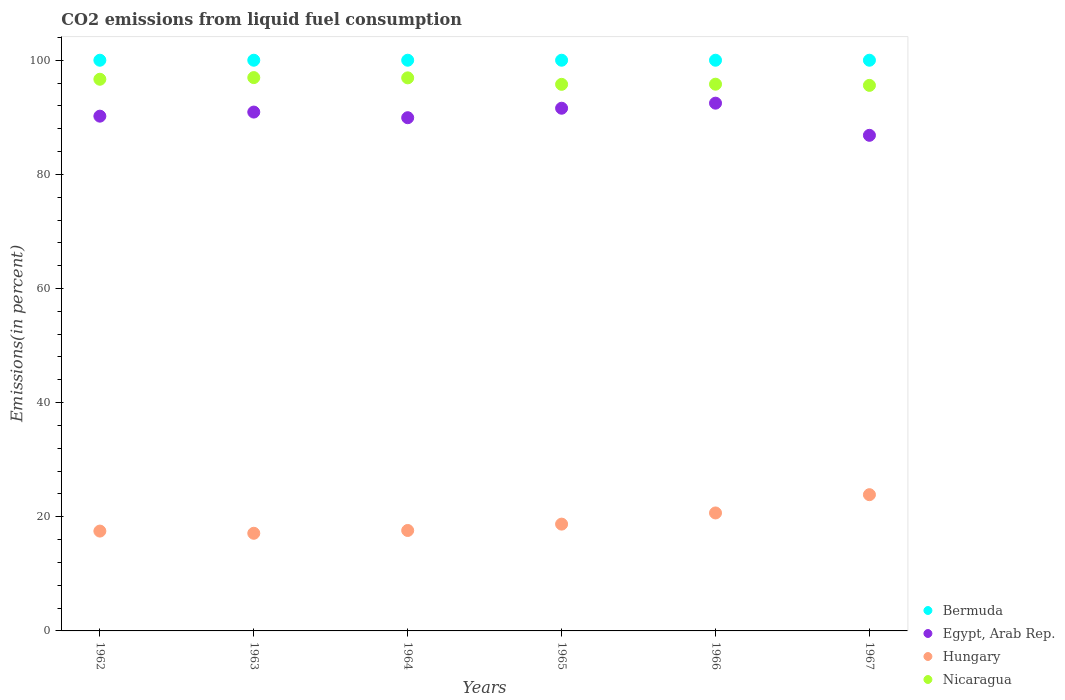How many different coloured dotlines are there?
Ensure brevity in your answer.  4. What is the total CO2 emitted in Nicaragua in 1964?
Ensure brevity in your answer.  96.91. Across all years, what is the maximum total CO2 emitted in Nicaragua?
Offer a very short reply. 96.96. Across all years, what is the minimum total CO2 emitted in Nicaragua?
Your response must be concise. 95.59. In which year was the total CO2 emitted in Hungary maximum?
Give a very brief answer. 1967. In which year was the total CO2 emitted in Nicaragua minimum?
Provide a short and direct response. 1967. What is the total total CO2 emitted in Hungary in the graph?
Provide a succinct answer. 115.46. What is the difference between the total CO2 emitted in Hungary in 1962 and the total CO2 emitted in Bermuda in 1963?
Offer a very short reply. -82.51. In the year 1967, what is the difference between the total CO2 emitted in Hungary and total CO2 emitted in Nicaragua?
Provide a short and direct response. -71.72. What is the ratio of the total CO2 emitted in Bermuda in 1963 to that in 1965?
Keep it short and to the point. 1. Is the difference between the total CO2 emitted in Hungary in 1962 and 1965 greater than the difference between the total CO2 emitted in Nicaragua in 1962 and 1965?
Ensure brevity in your answer.  No. What is the difference between the highest and the second highest total CO2 emitted in Hungary?
Keep it short and to the point. 3.2. What is the difference between the highest and the lowest total CO2 emitted in Egypt, Arab Rep.?
Offer a terse response. 5.63. In how many years, is the total CO2 emitted in Nicaragua greater than the average total CO2 emitted in Nicaragua taken over all years?
Provide a short and direct response. 3. Is the sum of the total CO2 emitted in Hungary in 1965 and 1966 greater than the maximum total CO2 emitted in Egypt, Arab Rep. across all years?
Provide a succinct answer. No. Is it the case that in every year, the sum of the total CO2 emitted in Hungary and total CO2 emitted in Egypt, Arab Rep.  is greater than the sum of total CO2 emitted in Bermuda and total CO2 emitted in Nicaragua?
Offer a terse response. No. Is it the case that in every year, the sum of the total CO2 emitted in Hungary and total CO2 emitted in Bermuda  is greater than the total CO2 emitted in Nicaragua?
Your answer should be very brief. Yes. How many years are there in the graph?
Offer a very short reply. 6. What is the difference between two consecutive major ticks on the Y-axis?
Your answer should be very brief. 20. Are the values on the major ticks of Y-axis written in scientific E-notation?
Your answer should be compact. No. Does the graph contain any zero values?
Your answer should be very brief. No. Does the graph contain grids?
Offer a very short reply. No. How many legend labels are there?
Provide a short and direct response. 4. What is the title of the graph?
Keep it short and to the point. CO2 emissions from liquid fuel consumption. Does "Lebanon" appear as one of the legend labels in the graph?
Your answer should be very brief. No. What is the label or title of the X-axis?
Offer a terse response. Years. What is the label or title of the Y-axis?
Your answer should be very brief. Emissions(in percent). What is the Emissions(in percent) in Egypt, Arab Rep. in 1962?
Provide a short and direct response. 90.2. What is the Emissions(in percent) of Hungary in 1962?
Make the answer very short. 17.49. What is the Emissions(in percent) in Nicaragua in 1962?
Provide a succinct answer. 96.67. What is the Emissions(in percent) in Egypt, Arab Rep. in 1963?
Make the answer very short. 90.92. What is the Emissions(in percent) of Hungary in 1963?
Ensure brevity in your answer.  17.11. What is the Emissions(in percent) in Nicaragua in 1963?
Your answer should be very brief. 96.96. What is the Emissions(in percent) in Bermuda in 1964?
Offer a terse response. 100. What is the Emissions(in percent) of Egypt, Arab Rep. in 1964?
Your answer should be compact. 89.93. What is the Emissions(in percent) in Hungary in 1964?
Keep it short and to the point. 17.6. What is the Emissions(in percent) of Nicaragua in 1964?
Provide a succinct answer. 96.91. What is the Emissions(in percent) of Bermuda in 1965?
Keep it short and to the point. 100. What is the Emissions(in percent) of Egypt, Arab Rep. in 1965?
Provide a short and direct response. 91.59. What is the Emissions(in percent) in Hungary in 1965?
Your response must be concise. 18.71. What is the Emissions(in percent) in Nicaragua in 1965?
Provide a short and direct response. 95.77. What is the Emissions(in percent) in Bermuda in 1966?
Offer a very short reply. 100. What is the Emissions(in percent) of Egypt, Arab Rep. in 1966?
Offer a terse response. 92.48. What is the Emissions(in percent) of Hungary in 1966?
Your answer should be very brief. 20.67. What is the Emissions(in percent) of Nicaragua in 1966?
Make the answer very short. 95.8. What is the Emissions(in percent) of Egypt, Arab Rep. in 1967?
Offer a terse response. 86.84. What is the Emissions(in percent) of Hungary in 1967?
Provide a succinct answer. 23.87. What is the Emissions(in percent) of Nicaragua in 1967?
Ensure brevity in your answer.  95.59. Across all years, what is the maximum Emissions(in percent) in Bermuda?
Give a very brief answer. 100. Across all years, what is the maximum Emissions(in percent) of Egypt, Arab Rep.?
Offer a terse response. 92.48. Across all years, what is the maximum Emissions(in percent) in Hungary?
Make the answer very short. 23.87. Across all years, what is the maximum Emissions(in percent) of Nicaragua?
Provide a succinct answer. 96.96. Across all years, what is the minimum Emissions(in percent) of Bermuda?
Offer a very short reply. 100. Across all years, what is the minimum Emissions(in percent) in Egypt, Arab Rep.?
Offer a terse response. 86.84. Across all years, what is the minimum Emissions(in percent) of Hungary?
Offer a terse response. 17.11. Across all years, what is the minimum Emissions(in percent) in Nicaragua?
Provide a short and direct response. 95.59. What is the total Emissions(in percent) of Bermuda in the graph?
Offer a terse response. 600. What is the total Emissions(in percent) in Egypt, Arab Rep. in the graph?
Your answer should be very brief. 541.95. What is the total Emissions(in percent) in Hungary in the graph?
Your answer should be compact. 115.46. What is the total Emissions(in percent) in Nicaragua in the graph?
Keep it short and to the point. 577.7. What is the difference between the Emissions(in percent) of Bermuda in 1962 and that in 1963?
Your answer should be compact. 0. What is the difference between the Emissions(in percent) in Egypt, Arab Rep. in 1962 and that in 1963?
Offer a terse response. -0.72. What is the difference between the Emissions(in percent) of Hungary in 1962 and that in 1963?
Make the answer very short. 0.38. What is the difference between the Emissions(in percent) of Nicaragua in 1962 and that in 1963?
Provide a succinct answer. -0.29. What is the difference between the Emissions(in percent) of Egypt, Arab Rep. in 1962 and that in 1964?
Provide a short and direct response. 0.27. What is the difference between the Emissions(in percent) of Hungary in 1962 and that in 1964?
Provide a short and direct response. -0.11. What is the difference between the Emissions(in percent) in Nicaragua in 1962 and that in 1964?
Give a very brief answer. -0.24. What is the difference between the Emissions(in percent) in Egypt, Arab Rep. in 1962 and that in 1965?
Make the answer very short. -1.39. What is the difference between the Emissions(in percent) of Hungary in 1962 and that in 1965?
Offer a very short reply. -1.22. What is the difference between the Emissions(in percent) of Nicaragua in 1962 and that in 1965?
Provide a succinct answer. 0.89. What is the difference between the Emissions(in percent) in Bermuda in 1962 and that in 1966?
Make the answer very short. 0. What is the difference between the Emissions(in percent) in Egypt, Arab Rep. in 1962 and that in 1966?
Your answer should be very brief. -2.28. What is the difference between the Emissions(in percent) in Hungary in 1962 and that in 1966?
Make the answer very short. -3.18. What is the difference between the Emissions(in percent) in Nicaragua in 1962 and that in 1966?
Your response must be concise. 0.87. What is the difference between the Emissions(in percent) in Egypt, Arab Rep. in 1962 and that in 1967?
Offer a terse response. 3.36. What is the difference between the Emissions(in percent) of Hungary in 1962 and that in 1967?
Your answer should be very brief. -6.38. What is the difference between the Emissions(in percent) in Nicaragua in 1962 and that in 1967?
Your answer should be very brief. 1.07. What is the difference between the Emissions(in percent) of Egypt, Arab Rep. in 1963 and that in 1964?
Offer a very short reply. 0.99. What is the difference between the Emissions(in percent) in Hungary in 1963 and that in 1964?
Provide a short and direct response. -0.49. What is the difference between the Emissions(in percent) in Nicaragua in 1963 and that in 1964?
Offer a terse response. 0.05. What is the difference between the Emissions(in percent) in Egypt, Arab Rep. in 1963 and that in 1965?
Provide a short and direct response. -0.67. What is the difference between the Emissions(in percent) in Hungary in 1963 and that in 1965?
Offer a terse response. -1.6. What is the difference between the Emissions(in percent) in Nicaragua in 1963 and that in 1965?
Make the answer very short. 1.18. What is the difference between the Emissions(in percent) of Egypt, Arab Rep. in 1963 and that in 1966?
Make the answer very short. -1.56. What is the difference between the Emissions(in percent) in Hungary in 1963 and that in 1966?
Provide a succinct answer. -3.56. What is the difference between the Emissions(in percent) of Nicaragua in 1963 and that in 1966?
Make the answer very short. 1.16. What is the difference between the Emissions(in percent) of Egypt, Arab Rep. in 1963 and that in 1967?
Your answer should be compact. 4.07. What is the difference between the Emissions(in percent) of Hungary in 1963 and that in 1967?
Provide a short and direct response. -6.76. What is the difference between the Emissions(in percent) of Nicaragua in 1963 and that in 1967?
Ensure brevity in your answer.  1.36. What is the difference between the Emissions(in percent) in Bermuda in 1964 and that in 1965?
Keep it short and to the point. 0. What is the difference between the Emissions(in percent) in Egypt, Arab Rep. in 1964 and that in 1965?
Your answer should be very brief. -1.66. What is the difference between the Emissions(in percent) in Hungary in 1964 and that in 1965?
Provide a succinct answer. -1.11. What is the difference between the Emissions(in percent) in Nicaragua in 1964 and that in 1965?
Your answer should be very brief. 1.14. What is the difference between the Emissions(in percent) in Egypt, Arab Rep. in 1964 and that in 1966?
Provide a short and direct response. -2.55. What is the difference between the Emissions(in percent) in Hungary in 1964 and that in 1966?
Ensure brevity in your answer.  -3.07. What is the difference between the Emissions(in percent) in Nicaragua in 1964 and that in 1966?
Provide a short and direct response. 1.11. What is the difference between the Emissions(in percent) in Egypt, Arab Rep. in 1964 and that in 1967?
Keep it short and to the point. 3.09. What is the difference between the Emissions(in percent) of Hungary in 1964 and that in 1967?
Provide a short and direct response. -6.27. What is the difference between the Emissions(in percent) of Nicaragua in 1964 and that in 1967?
Your response must be concise. 1.32. What is the difference between the Emissions(in percent) of Bermuda in 1965 and that in 1966?
Provide a succinct answer. 0. What is the difference between the Emissions(in percent) of Egypt, Arab Rep. in 1965 and that in 1966?
Your response must be concise. -0.89. What is the difference between the Emissions(in percent) of Hungary in 1965 and that in 1966?
Ensure brevity in your answer.  -1.96. What is the difference between the Emissions(in percent) in Nicaragua in 1965 and that in 1966?
Keep it short and to the point. -0.03. What is the difference between the Emissions(in percent) in Egypt, Arab Rep. in 1965 and that in 1967?
Provide a short and direct response. 4.75. What is the difference between the Emissions(in percent) in Hungary in 1965 and that in 1967?
Keep it short and to the point. -5.16. What is the difference between the Emissions(in percent) in Nicaragua in 1965 and that in 1967?
Offer a terse response. 0.18. What is the difference between the Emissions(in percent) in Egypt, Arab Rep. in 1966 and that in 1967?
Give a very brief answer. 5.63. What is the difference between the Emissions(in percent) of Hungary in 1966 and that in 1967?
Offer a very short reply. -3.2. What is the difference between the Emissions(in percent) of Nicaragua in 1966 and that in 1967?
Offer a very short reply. 0.21. What is the difference between the Emissions(in percent) of Bermuda in 1962 and the Emissions(in percent) of Egypt, Arab Rep. in 1963?
Offer a terse response. 9.08. What is the difference between the Emissions(in percent) in Bermuda in 1962 and the Emissions(in percent) in Hungary in 1963?
Your answer should be compact. 82.89. What is the difference between the Emissions(in percent) of Bermuda in 1962 and the Emissions(in percent) of Nicaragua in 1963?
Your answer should be very brief. 3.04. What is the difference between the Emissions(in percent) of Egypt, Arab Rep. in 1962 and the Emissions(in percent) of Hungary in 1963?
Ensure brevity in your answer.  73.09. What is the difference between the Emissions(in percent) of Egypt, Arab Rep. in 1962 and the Emissions(in percent) of Nicaragua in 1963?
Ensure brevity in your answer.  -6.76. What is the difference between the Emissions(in percent) in Hungary in 1962 and the Emissions(in percent) in Nicaragua in 1963?
Ensure brevity in your answer.  -79.46. What is the difference between the Emissions(in percent) of Bermuda in 1962 and the Emissions(in percent) of Egypt, Arab Rep. in 1964?
Give a very brief answer. 10.07. What is the difference between the Emissions(in percent) of Bermuda in 1962 and the Emissions(in percent) of Hungary in 1964?
Offer a terse response. 82.4. What is the difference between the Emissions(in percent) in Bermuda in 1962 and the Emissions(in percent) in Nicaragua in 1964?
Give a very brief answer. 3.09. What is the difference between the Emissions(in percent) in Egypt, Arab Rep. in 1962 and the Emissions(in percent) in Hungary in 1964?
Offer a very short reply. 72.6. What is the difference between the Emissions(in percent) of Egypt, Arab Rep. in 1962 and the Emissions(in percent) of Nicaragua in 1964?
Give a very brief answer. -6.71. What is the difference between the Emissions(in percent) of Hungary in 1962 and the Emissions(in percent) of Nicaragua in 1964?
Your response must be concise. -79.42. What is the difference between the Emissions(in percent) in Bermuda in 1962 and the Emissions(in percent) in Egypt, Arab Rep. in 1965?
Your answer should be very brief. 8.41. What is the difference between the Emissions(in percent) in Bermuda in 1962 and the Emissions(in percent) in Hungary in 1965?
Ensure brevity in your answer.  81.29. What is the difference between the Emissions(in percent) in Bermuda in 1962 and the Emissions(in percent) in Nicaragua in 1965?
Your response must be concise. 4.23. What is the difference between the Emissions(in percent) of Egypt, Arab Rep. in 1962 and the Emissions(in percent) of Hungary in 1965?
Provide a succinct answer. 71.49. What is the difference between the Emissions(in percent) of Egypt, Arab Rep. in 1962 and the Emissions(in percent) of Nicaragua in 1965?
Your response must be concise. -5.58. What is the difference between the Emissions(in percent) in Hungary in 1962 and the Emissions(in percent) in Nicaragua in 1965?
Keep it short and to the point. -78.28. What is the difference between the Emissions(in percent) in Bermuda in 1962 and the Emissions(in percent) in Egypt, Arab Rep. in 1966?
Your answer should be compact. 7.52. What is the difference between the Emissions(in percent) of Bermuda in 1962 and the Emissions(in percent) of Hungary in 1966?
Offer a very short reply. 79.33. What is the difference between the Emissions(in percent) in Bermuda in 1962 and the Emissions(in percent) in Nicaragua in 1966?
Ensure brevity in your answer.  4.2. What is the difference between the Emissions(in percent) in Egypt, Arab Rep. in 1962 and the Emissions(in percent) in Hungary in 1966?
Your answer should be very brief. 69.53. What is the difference between the Emissions(in percent) in Egypt, Arab Rep. in 1962 and the Emissions(in percent) in Nicaragua in 1966?
Your response must be concise. -5.6. What is the difference between the Emissions(in percent) in Hungary in 1962 and the Emissions(in percent) in Nicaragua in 1966?
Your answer should be compact. -78.31. What is the difference between the Emissions(in percent) in Bermuda in 1962 and the Emissions(in percent) in Egypt, Arab Rep. in 1967?
Make the answer very short. 13.16. What is the difference between the Emissions(in percent) of Bermuda in 1962 and the Emissions(in percent) of Hungary in 1967?
Give a very brief answer. 76.13. What is the difference between the Emissions(in percent) in Bermuda in 1962 and the Emissions(in percent) in Nicaragua in 1967?
Provide a short and direct response. 4.41. What is the difference between the Emissions(in percent) in Egypt, Arab Rep. in 1962 and the Emissions(in percent) in Hungary in 1967?
Keep it short and to the point. 66.33. What is the difference between the Emissions(in percent) in Egypt, Arab Rep. in 1962 and the Emissions(in percent) in Nicaragua in 1967?
Your answer should be very brief. -5.39. What is the difference between the Emissions(in percent) of Hungary in 1962 and the Emissions(in percent) of Nicaragua in 1967?
Provide a short and direct response. -78.1. What is the difference between the Emissions(in percent) in Bermuda in 1963 and the Emissions(in percent) in Egypt, Arab Rep. in 1964?
Offer a very short reply. 10.07. What is the difference between the Emissions(in percent) of Bermuda in 1963 and the Emissions(in percent) of Hungary in 1964?
Ensure brevity in your answer.  82.4. What is the difference between the Emissions(in percent) of Bermuda in 1963 and the Emissions(in percent) of Nicaragua in 1964?
Provide a succinct answer. 3.09. What is the difference between the Emissions(in percent) in Egypt, Arab Rep. in 1963 and the Emissions(in percent) in Hungary in 1964?
Your answer should be compact. 73.32. What is the difference between the Emissions(in percent) in Egypt, Arab Rep. in 1963 and the Emissions(in percent) in Nicaragua in 1964?
Ensure brevity in your answer.  -6. What is the difference between the Emissions(in percent) of Hungary in 1963 and the Emissions(in percent) of Nicaragua in 1964?
Ensure brevity in your answer.  -79.8. What is the difference between the Emissions(in percent) of Bermuda in 1963 and the Emissions(in percent) of Egypt, Arab Rep. in 1965?
Offer a very short reply. 8.41. What is the difference between the Emissions(in percent) of Bermuda in 1963 and the Emissions(in percent) of Hungary in 1965?
Provide a short and direct response. 81.29. What is the difference between the Emissions(in percent) in Bermuda in 1963 and the Emissions(in percent) in Nicaragua in 1965?
Your answer should be compact. 4.23. What is the difference between the Emissions(in percent) in Egypt, Arab Rep. in 1963 and the Emissions(in percent) in Hungary in 1965?
Your answer should be compact. 72.2. What is the difference between the Emissions(in percent) in Egypt, Arab Rep. in 1963 and the Emissions(in percent) in Nicaragua in 1965?
Offer a terse response. -4.86. What is the difference between the Emissions(in percent) of Hungary in 1963 and the Emissions(in percent) of Nicaragua in 1965?
Provide a succinct answer. -78.66. What is the difference between the Emissions(in percent) in Bermuda in 1963 and the Emissions(in percent) in Egypt, Arab Rep. in 1966?
Make the answer very short. 7.52. What is the difference between the Emissions(in percent) in Bermuda in 1963 and the Emissions(in percent) in Hungary in 1966?
Your response must be concise. 79.33. What is the difference between the Emissions(in percent) in Bermuda in 1963 and the Emissions(in percent) in Nicaragua in 1966?
Your response must be concise. 4.2. What is the difference between the Emissions(in percent) of Egypt, Arab Rep. in 1963 and the Emissions(in percent) of Hungary in 1966?
Give a very brief answer. 70.24. What is the difference between the Emissions(in percent) of Egypt, Arab Rep. in 1963 and the Emissions(in percent) of Nicaragua in 1966?
Your answer should be compact. -4.89. What is the difference between the Emissions(in percent) in Hungary in 1963 and the Emissions(in percent) in Nicaragua in 1966?
Make the answer very short. -78.69. What is the difference between the Emissions(in percent) of Bermuda in 1963 and the Emissions(in percent) of Egypt, Arab Rep. in 1967?
Ensure brevity in your answer.  13.16. What is the difference between the Emissions(in percent) in Bermuda in 1963 and the Emissions(in percent) in Hungary in 1967?
Provide a succinct answer. 76.13. What is the difference between the Emissions(in percent) of Bermuda in 1963 and the Emissions(in percent) of Nicaragua in 1967?
Keep it short and to the point. 4.41. What is the difference between the Emissions(in percent) in Egypt, Arab Rep. in 1963 and the Emissions(in percent) in Hungary in 1967?
Your response must be concise. 67.04. What is the difference between the Emissions(in percent) in Egypt, Arab Rep. in 1963 and the Emissions(in percent) in Nicaragua in 1967?
Keep it short and to the point. -4.68. What is the difference between the Emissions(in percent) of Hungary in 1963 and the Emissions(in percent) of Nicaragua in 1967?
Provide a short and direct response. -78.48. What is the difference between the Emissions(in percent) in Bermuda in 1964 and the Emissions(in percent) in Egypt, Arab Rep. in 1965?
Offer a terse response. 8.41. What is the difference between the Emissions(in percent) of Bermuda in 1964 and the Emissions(in percent) of Hungary in 1965?
Provide a succinct answer. 81.29. What is the difference between the Emissions(in percent) of Bermuda in 1964 and the Emissions(in percent) of Nicaragua in 1965?
Your answer should be very brief. 4.23. What is the difference between the Emissions(in percent) of Egypt, Arab Rep. in 1964 and the Emissions(in percent) of Hungary in 1965?
Keep it short and to the point. 71.21. What is the difference between the Emissions(in percent) in Egypt, Arab Rep. in 1964 and the Emissions(in percent) in Nicaragua in 1965?
Make the answer very short. -5.85. What is the difference between the Emissions(in percent) in Hungary in 1964 and the Emissions(in percent) in Nicaragua in 1965?
Make the answer very short. -78.17. What is the difference between the Emissions(in percent) in Bermuda in 1964 and the Emissions(in percent) in Egypt, Arab Rep. in 1966?
Your answer should be compact. 7.52. What is the difference between the Emissions(in percent) of Bermuda in 1964 and the Emissions(in percent) of Hungary in 1966?
Make the answer very short. 79.33. What is the difference between the Emissions(in percent) of Bermuda in 1964 and the Emissions(in percent) of Nicaragua in 1966?
Give a very brief answer. 4.2. What is the difference between the Emissions(in percent) in Egypt, Arab Rep. in 1964 and the Emissions(in percent) in Hungary in 1966?
Offer a terse response. 69.26. What is the difference between the Emissions(in percent) of Egypt, Arab Rep. in 1964 and the Emissions(in percent) of Nicaragua in 1966?
Keep it short and to the point. -5.87. What is the difference between the Emissions(in percent) in Hungary in 1964 and the Emissions(in percent) in Nicaragua in 1966?
Give a very brief answer. -78.2. What is the difference between the Emissions(in percent) of Bermuda in 1964 and the Emissions(in percent) of Egypt, Arab Rep. in 1967?
Keep it short and to the point. 13.16. What is the difference between the Emissions(in percent) in Bermuda in 1964 and the Emissions(in percent) in Hungary in 1967?
Make the answer very short. 76.13. What is the difference between the Emissions(in percent) in Bermuda in 1964 and the Emissions(in percent) in Nicaragua in 1967?
Keep it short and to the point. 4.41. What is the difference between the Emissions(in percent) of Egypt, Arab Rep. in 1964 and the Emissions(in percent) of Hungary in 1967?
Ensure brevity in your answer.  66.05. What is the difference between the Emissions(in percent) in Egypt, Arab Rep. in 1964 and the Emissions(in percent) in Nicaragua in 1967?
Provide a succinct answer. -5.67. What is the difference between the Emissions(in percent) in Hungary in 1964 and the Emissions(in percent) in Nicaragua in 1967?
Offer a very short reply. -77.99. What is the difference between the Emissions(in percent) in Bermuda in 1965 and the Emissions(in percent) in Egypt, Arab Rep. in 1966?
Offer a terse response. 7.52. What is the difference between the Emissions(in percent) in Bermuda in 1965 and the Emissions(in percent) in Hungary in 1966?
Offer a very short reply. 79.33. What is the difference between the Emissions(in percent) of Bermuda in 1965 and the Emissions(in percent) of Nicaragua in 1966?
Offer a very short reply. 4.2. What is the difference between the Emissions(in percent) in Egypt, Arab Rep. in 1965 and the Emissions(in percent) in Hungary in 1966?
Give a very brief answer. 70.92. What is the difference between the Emissions(in percent) in Egypt, Arab Rep. in 1965 and the Emissions(in percent) in Nicaragua in 1966?
Offer a very short reply. -4.21. What is the difference between the Emissions(in percent) in Hungary in 1965 and the Emissions(in percent) in Nicaragua in 1966?
Keep it short and to the point. -77.09. What is the difference between the Emissions(in percent) in Bermuda in 1965 and the Emissions(in percent) in Egypt, Arab Rep. in 1967?
Your response must be concise. 13.16. What is the difference between the Emissions(in percent) in Bermuda in 1965 and the Emissions(in percent) in Hungary in 1967?
Keep it short and to the point. 76.13. What is the difference between the Emissions(in percent) of Bermuda in 1965 and the Emissions(in percent) of Nicaragua in 1967?
Provide a short and direct response. 4.41. What is the difference between the Emissions(in percent) of Egypt, Arab Rep. in 1965 and the Emissions(in percent) of Hungary in 1967?
Provide a short and direct response. 67.72. What is the difference between the Emissions(in percent) in Egypt, Arab Rep. in 1965 and the Emissions(in percent) in Nicaragua in 1967?
Your answer should be very brief. -4. What is the difference between the Emissions(in percent) in Hungary in 1965 and the Emissions(in percent) in Nicaragua in 1967?
Provide a short and direct response. -76.88. What is the difference between the Emissions(in percent) in Bermuda in 1966 and the Emissions(in percent) in Egypt, Arab Rep. in 1967?
Provide a short and direct response. 13.16. What is the difference between the Emissions(in percent) of Bermuda in 1966 and the Emissions(in percent) of Hungary in 1967?
Ensure brevity in your answer.  76.13. What is the difference between the Emissions(in percent) of Bermuda in 1966 and the Emissions(in percent) of Nicaragua in 1967?
Your answer should be compact. 4.41. What is the difference between the Emissions(in percent) in Egypt, Arab Rep. in 1966 and the Emissions(in percent) in Hungary in 1967?
Provide a short and direct response. 68.6. What is the difference between the Emissions(in percent) in Egypt, Arab Rep. in 1966 and the Emissions(in percent) in Nicaragua in 1967?
Make the answer very short. -3.12. What is the difference between the Emissions(in percent) of Hungary in 1966 and the Emissions(in percent) of Nicaragua in 1967?
Give a very brief answer. -74.92. What is the average Emissions(in percent) in Egypt, Arab Rep. per year?
Provide a succinct answer. 90.33. What is the average Emissions(in percent) in Hungary per year?
Make the answer very short. 19.24. What is the average Emissions(in percent) in Nicaragua per year?
Offer a terse response. 96.28. In the year 1962, what is the difference between the Emissions(in percent) of Bermuda and Emissions(in percent) of Egypt, Arab Rep.?
Provide a short and direct response. 9.8. In the year 1962, what is the difference between the Emissions(in percent) in Bermuda and Emissions(in percent) in Hungary?
Give a very brief answer. 82.51. In the year 1962, what is the difference between the Emissions(in percent) of Bermuda and Emissions(in percent) of Nicaragua?
Keep it short and to the point. 3.33. In the year 1962, what is the difference between the Emissions(in percent) in Egypt, Arab Rep. and Emissions(in percent) in Hungary?
Provide a short and direct response. 72.71. In the year 1962, what is the difference between the Emissions(in percent) of Egypt, Arab Rep. and Emissions(in percent) of Nicaragua?
Keep it short and to the point. -6.47. In the year 1962, what is the difference between the Emissions(in percent) in Hungary and Emissions(in percent) in Nicaragua?
Make the answer very short. -79.17. In the year 1963, what is the difference between the Emissions(in percent) in Bermuda and Emissions(in percent) in Egypt, Arab Rep.?
Provide a short and direct response. 9.08. In the year 1963, what is the difference between the Emissions(in percent) of Bermuda and Emissions(in percent) of Hungary?
Make the answer very short. 82.89. In the year 1963, what is the difference between the Emissions(in percent) of Bermuda and Emissions(in percent) of Nicaragua?
Offer a very short reply. 3.04. In the year 1963, what is the difference between the Emissions(in percent) of Egypt, Arab Rep. and Emissions(in percent) of Hungary?
Your response must be concise. 73.81. In the year 1963, what is the difference between the Emissions(in percent) of Egypt, Arab Rep. and Emissions(in percent) of Nicaragua?
Your answer should be very brief. -6.04. In the year 1963, what is the difference between the Emissions(in percent) of Hungary and Emissions(in percent) of Nicaragua?
Your response must be concise. -79.85. In the year 1964, what is the difference between the Emissions(in percent) in Bermuda and Emissions(in percent) in Egypt, Arab Rep.?
Your response must be concise. 10.07. In the year 1964, what is the difference between the Emissions(in percent) in Bermuda and Emissions(in percent) in Hungary?
Your response must be concise. 82.4. In the year 1964, what is the difference between the Emissions(in percent) of Bermuda and Emissions(in percent) of Nicaragua?
Your response must be concise. 3.09. In the year 1964, what is the difference between the Emissions(in percent) of Egypt, Arab Rep. and Emissions(in percent) of Hungary?
Your answer should be compact. 72.33. In the year 1964, what is the difference between the Emissions(in percent) in Egypt, Arab Rep. and Emissions(in percent) in Nicaragua?
Give a very brief answer. -6.98. In the year 1964, what is the difference between the Emissions(in percent) of Hungary and Emissions(in percent) of Nicaragua?
Keep it short and to the point. -79.31. In the year 1965, what is the difference between the Emissions(in percent) in Bermuda and Emissions(in percent) in Egypt, Arab Rep.?
Offer a very short reply. 8.41. In the year 1965, what is the difference between the Emissions(in percent) of Bermuda and Emissions(in percent) of Hungary?
Offer a terse response. 81.29. In the year 1965, what is the difference between the Emissions(in percent) of Bermuda and Emissions(in percent) of Nicaragua?
Make the answer very short. 4.23. In the year 1965, what is the difference between the Emissions(in percent) in Egypt, Arab Rep. and Emissions(in percent) in Hungary?
Provide a succinct answer. 72.88. In the year 1965, what is the difference between the Emissions(in percent) in Egypt, Arab Rep. and Emissions(in percent) in Nicaragua?
Provide a short and direct response. -4.19. In the year 1965, what is the difference between the Emissions(in percent) of Hungary and Emissions(in percent) of Nicaragua?
Ensure brevity in your answer.  -77.06. In the year 1966, what is the difference between the Emissions(in percent) of Bermuda and Emissions(in percent) of Egypt, Arab Rep.?
Your answer should be compact. 7.52. In the year 1966, what is the difference between the Emissions(in percent) in Bermuda and Emissions(in percent) in Hungary?
Provide a short and direct response. 79.33. In the year 1966, what is the difference between the Emissions(in percent) in Bermuda and Emissions(in percent) in Nicaragua?
Your response must be concise. 4.2. In the year 1966, what is the difference between the Emissions(in percent) in Egypt, Arab Rep. and Emissions(in percent) in Hungary?
Make the answer very short. 71.81. In the year 1966, what is the difference between the Emissions(in percent) in Egypt, Arab Rep. and Emissions(in percent) in Nicaragua?
Provide a succinct answer. -3.33. In the year 1966, what is the difference between the Emissions(in percent) in Hungary and Emissions(in percent) in Nicaragua?
Make the answer very short. -75.13. In the year 1967, what is the difference between the Emissions(in percent) in Bermuda and Emissions(in percent) in Egypt, Arab Rep.?
Give a very brief answer. 13.16. In the year 1967, what is the difference between the Emissions(in percent) in Bermuda and Emissions(in percent) in Hungary?
Your answer should be very brief. 76.13. In the year 1967, what is the difference between the Emissions(in percent) in Bermuda and Emissions(in percent) in Nicaragua?
Provide a succinct answer. 4.41. In the year 1967, what is the difference between the Emissions(in percent) of Egypt, Arab Rep. and Emissions(in percent) of Hungary?
Your response must be concise. 62.97. In the year 1967, what is the difference between the Emissions(in percent) of Egypt, Arab Rep. and Emissions(in percent) of Nicaragua?
Give a very brief answer. -8.75. In the year 1967, what is the difference between the Emissions(in percent) in Hungary and Emissions(in percent) in Nicaragua?
Ensure brevity in your answer.  -71.72. What is the ratio of the Emissions(in percent) of Hungary in 1962 to that in 1963?
Keep it short and to the point. 1.02. What is the ratio of the Emissions(in percent) in Bermuda in 1962 to that in 1964?
Make the answer very short. 1. What is the ratio of the Emissions(in percent) in Egypt, Arab Rep. in 1962 to that in 1964?
Ensure brevity in your answer.  1. What is the ratio of the Emissions(in percent) of Hungary in 1962 to that in 1964?
Provide a short and direct response. 0.99. What is the ratio of the Emissions(in percent) of Nicaragua in 1962 to that in 1964?
Keep it short and to the point. 1. What is the ratio of the Emissions(in percent) of Egypt, Arab Rep. in 1962 to that in 1965?
Keep it short and to the point. 0.98. What is the ratio of the Emissions(in percent) in Hungary in 1962 to that in 1965?
Offer a very short reply. 0.93. What is the ratio of the Emissions(in percent) of Nicaragua in 1962 to that in 1965?
Your answer should be very brief. 1.01. What is the ratio of the Emissions(in percent) of Bermuda in 1962 to that in 1966?
Ensure brevity in your answer.  1. What is the ratio of the Emissions(in percent) in Egypt, Arab Rep. in 1962 to that in 1966?
Make the answer very short. 0.98. What is the ratio of the Emissions(in percent) in Hungary in 1962 to that in 1966?
Keep it short and to the point. 0.85. What is the ratio of the Emissions(in percent) of Nicaragua in 1962 to that in 1966?
Ensure brevity in your answer.  1.01. What is the ratio of the Emissions(in percent) of Egypt, Arab Rep. in 1962 to that in 1967?
Provide a succinct answer. 1.04. What is the ratio of the Emissions(in percent) in Hungary in 1962 to that in 1967?
Give a very brief answer. 0.73. What is the ratio of the Emissions(in percent) of Nicaragua in 1962 to that in 1967?
Ensure brevity in your answer.  1.01. What is the ratio of the Emissions(in percent) in Bermuda in 1963 to that in 1964?
Your answer should be very brief. 1. What is the ratio of the Emissions(in percent) of Hungary in 1963 to that in 1964?
Offer a very short reply. 0.97. What is the ratio of the Emissions(in percent) of Nicaragua in 1963 to that in 1964?
Offer a very short reply. 1. What is the ratio of the Emissions(in percent) of Bermuda in 1963 to that in 1965?
Provide a short and direct response. 1. What is the ratio of the Emissions(in percent) in Hungary in 1963 to that in 1965?
Provide a short and direct response. 0.91. What is the ratio of the Emissions(in percent) in Nicaragua in 1963 to that in 1965?
Your answer should be very brief. 1.01. What is the ratio of the Emissions(in percent) of Bermuda in 1963 to that in 1966?
Your response must be concise. 1. What is the ratio of the Emissions(in percent) in Egypt, Arab Rep. in 1963 to that in 1966?
Your answer should be very brief. 0.98. What is the ratio of the Emissions(in percent) in Hungary in 1963 to that in 1966?
Your response must be concise. 0.83. What is the ratio of the Emissions(in percent) in Nicaragua in 1963 to that in 1966?
Your response must be concise. 1.01. What is the ratio of the Emissions(in percent) in Bermuda in 1963 to that in 1967?
Provide a succinct answer. 1. What is the ratio of the Emissions(in percent) of Egypt, Arab Rep. in 1963 to that in 1967?
Ensure brevity in your answer.  1.05. What is the ratio of the Emissions(in percent) of Hungary in 1963 to that in 1967?
Make the answer very short. 0.72. What is the ratio of the Emissions(in percent) of Nicaragua in 1963 to that in 1967?
Offer a terse response. 1.01. What is the ratio of the Emissions(in percent) in Egypt, Arab Rep. in 1964 to that in 1965?
Ensure brevity in your answer.  0.98. What is the ratio of the Emissions(in percent) in Hungary in 1964 to that in 1965?
Offer a very short reply. 0.94. What is the ratio of the Emissions(in percent) of Nicaragua in 1964 to that in 1965?
Offer a very short reply. 1.01. What is the ratio of the Emissions(in percent) of Egypt, Arab Rep. in 1964 to that in 1966?
Give a very brief answer. 0.97. What is the ratio of the Emissions(in percent) in Hungary in 1964 to that in 1966?
Give a very brief answer. 0.85. What is the ratio of the Emissions(in percent) of Nicaragua in 1964 to that in 1966?
Ensure brevity in your answer.  1.01. What is the ratio of the Emissions(in percent) in Egypt, Arab Rep. in 1964 to that in 1967?
Keep it short and to the point. 1.04. What is the ratio of the Emissions(in percent) of Hungary in 1964 to that in 1967?
Ensure brevity in your answer.  0.74. What is the ratio of the Emissions(in percent) of Nicaragua in 1964 to that in 1967?
Provide a short and direct response. 1.01. What is the ratio of the Emissions(in percent) of Bermuda in 1965 to that in 1966?
Your answer should be very brief. 1. What is the ratio of the Emissions(in percent) in Egypt, Arab Rep. in 1965 to that in 1966?
Your answer should be compact. 0.99. What is the ratio of the Emissions(in percent) in Hungary in 1965 to that in 1966?
Offer a very short reply. 0.91. What is the ratio of the Emissions(in percent) of Nicaragua in 1965 to that in 1966?
Offer a terse response. 1. What is the ratio of the Emissions(in percent) of Bermuda in 1965 to that in 1967?
Offer a very short reply. 1. What is the ratio of the Emissions(in percent) of Egypt, Arab Rep. in 1965 to that in 1967?
Provide a succinct answer. 1.05. What is the ratio of the Emissions(in percent) in Hungary in 1965 to that in 1967?
Keep it short and to the point. 0.78. What is the ratio of the Emissions(in percent) of Nicaragua in 1965 to that in 1967?
Your response must be concise. 1. What is the ratio of the Emissions(in percent) in Bermuda in 1966 to that in 1967?
Your answer should be very brief. 1. What is the ratio of the Emissions(in percent) in Egypt, Arab Rep. in 1966 to that in 1967?
Ensure brevity in your answer.  1.06. What is the ratio of the Emissions(in percent) of Hungary in 1966 to that in 1967?
Offer a very short reply. 0.87. What is the ratio of the Emissions(in percent) in Nicaragua in 1966 to that in 1967?
Ensure brevity in your answer.  1. What is the difference between the highest and the second highest Emissions(in percent) of Bermuda?
Give a very brief answer. 0. What is the difference between the highest and the second highest Emissions(in percent) of Egypt, Arab Rep.?
Your answer should be compact. 0.89. What is the difference between the highest and the second highest Emissions(in percent) of Hungary?
Offer a very short reply. 3.2. What is the difference between the highest and the second highest Emissions(in percent) of Nicaragua?
Offer a terse response. 0.05. What is the difference between the highest and the lowest Emissions(in percent) in Bermuda?
Provide a short and direct response. 0. What is the difference between the highest and the lowest Emissions(in percent) in Egypt, Arab Rep.?
Provide a short and direct response. 5.63. What is the difference between the highest and the lowest Emissions(in percent) of Hungary?
Give a very brief answer. 6.76. What is the difference between the highest and the lowest Emissions(in percent) of Nicaragua?
Keep it short and to the point. 1.36. 